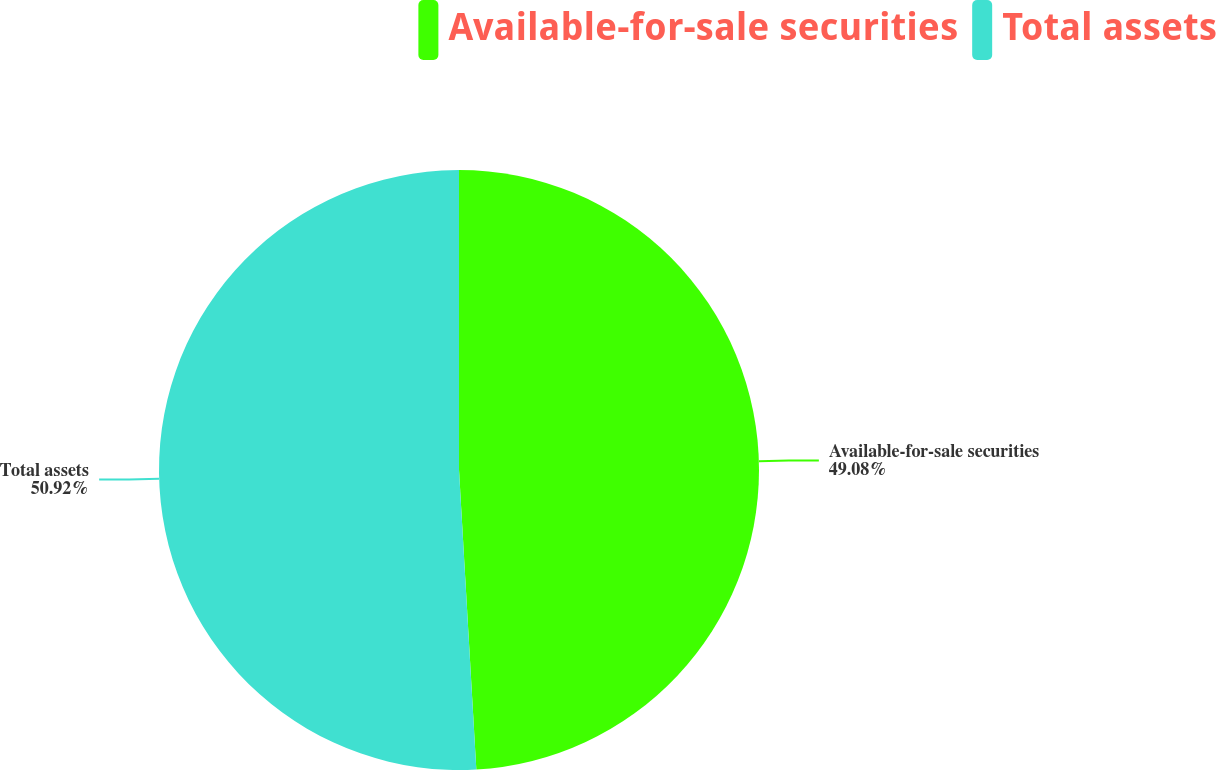<chart> <loc_0><loc_0><loc_500><loc_500><pie_chart><fcel>Available-for-sale securities<fcel>Total assets<nl><fcel>49.08%<fcel>50.92%<nl></chart> 